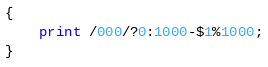<code> <loc_0><loc_0><loc_500><loc_500><_Awk_>{
	print /000/?0:1000-$1%1000;
}</code> 